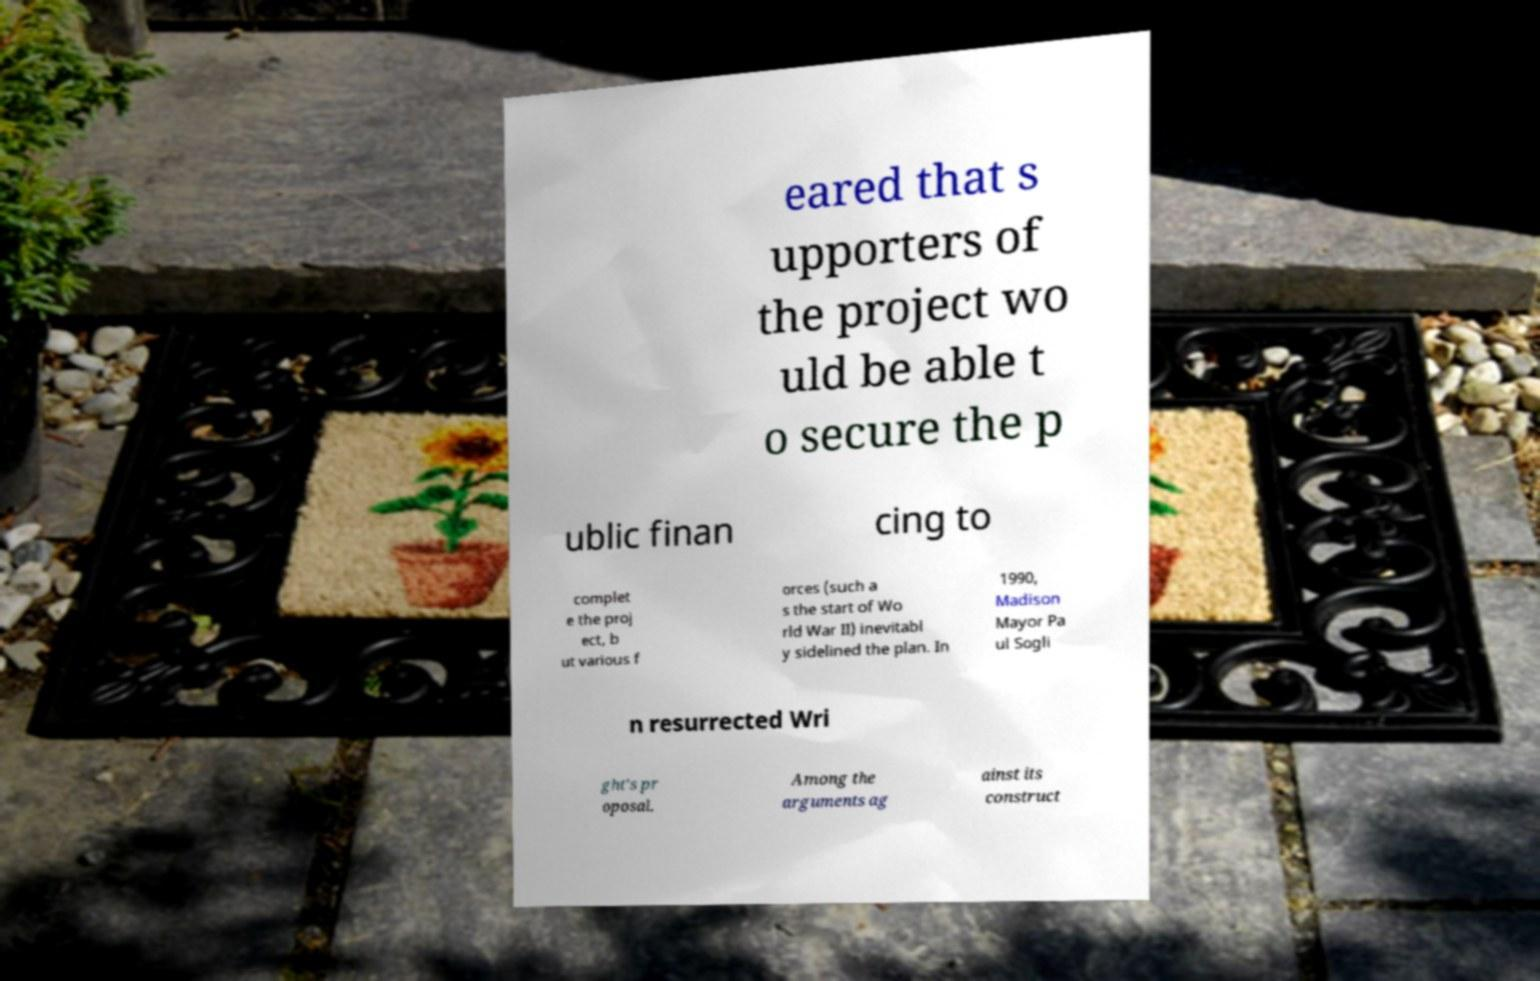For documentation purposes, I need the text within this image transcribed. Could you provide that? eared that s upporters of the project wo uld be able t o secure the p ublic finan cing to complet e the proj ect, b ut various f orces (such a s the start of Wo rld War II) inevitabl y sidelined the plan. In 1990, Madison Mayor Pa ul Sogli n resurrected Wri ght's pr oposal. Among the arguments ag ainst its construct 